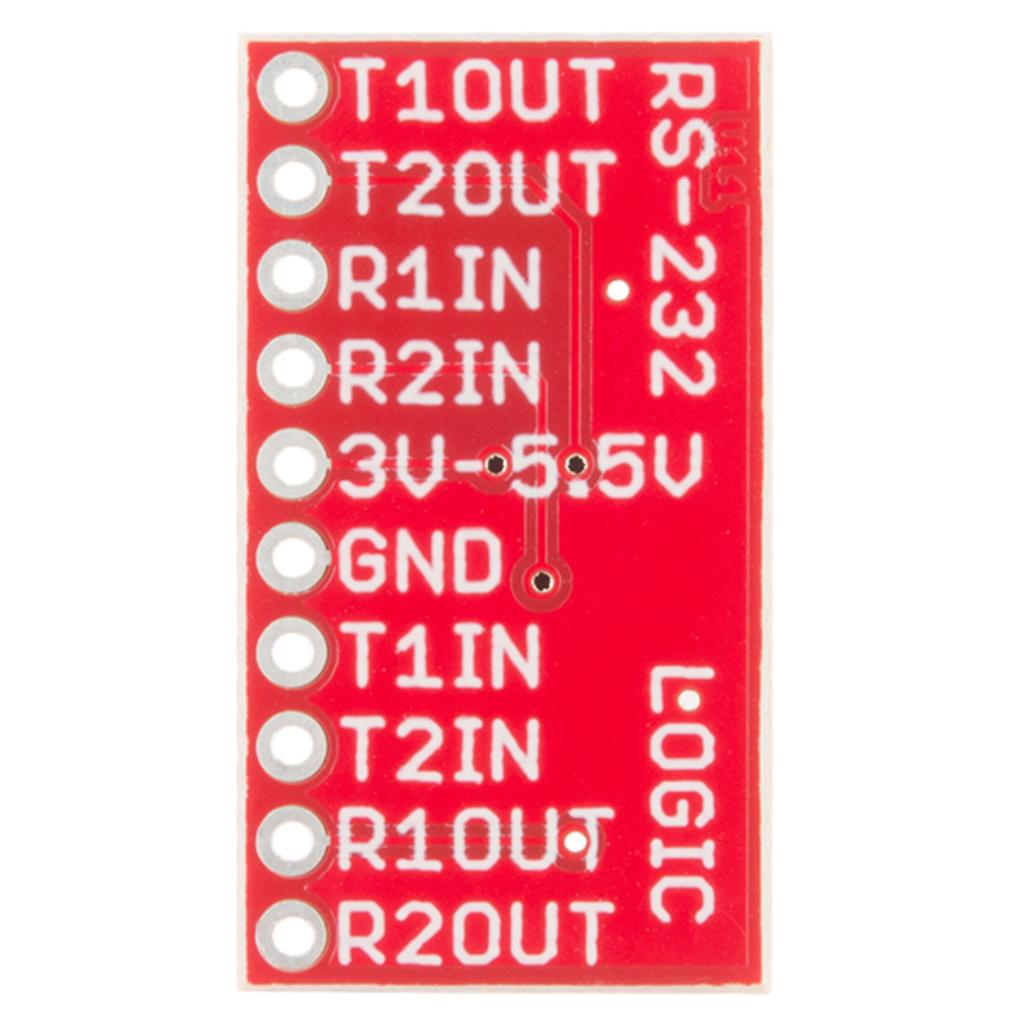Provide a one-sentence caption for the provided image. A close up of a red Logic circuit board with numbered terminals. 